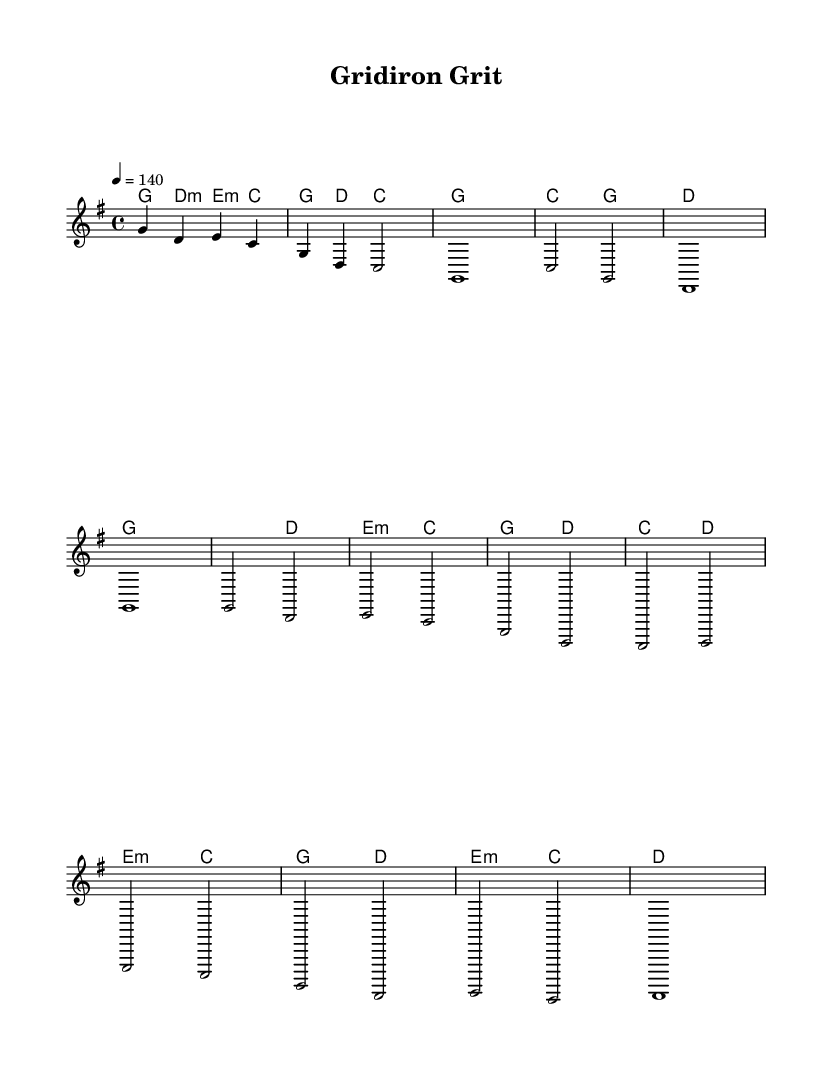What is the key signature of this music? The key signature is indicated at the beginning of the staff. It is G major, which has one sharp (F#).
Answer: G major What is the time signature of this music? The time signature is shown at the beginning of the score. It indicates a 4/4 time signature, meaning there are four beats in a measure, and the quarter note gets one beat.
Answer: 4/4 What is the tempo marking in this piece? The tempo marking is found at the beginning of the score. It indicates to play at a speed of 140 beats per minute, denoted by “4 = 140.”
Answer: 140 How many measures are in the chorus section? To find the number of measures in the chorus, we need to count the measures specifically marked as the chorus. There are four measures in this section of the piece.
Answer: 4 What chords are used in the bridge section? By examining the harmony line under the bridge section, the chords are E minor, C major, G major, and D major. They are specified in the harmony line.
Answer: E minor, C major, G major, D major What is the primary theme of the melody? The primary theme can be inferred from the melody pattern throughout the piece. It features a repetitive and uplifting character fitting for a pre-game atmosphere, typical of upbeat country music.
Answer: Uplifting How many different sections does the piece have? By analyzing the structure in the score, there are four distinct sections: Intro, Verse, Chorus, and Bridge. This provides a varied format typical in country tracks.
Answer: 4 